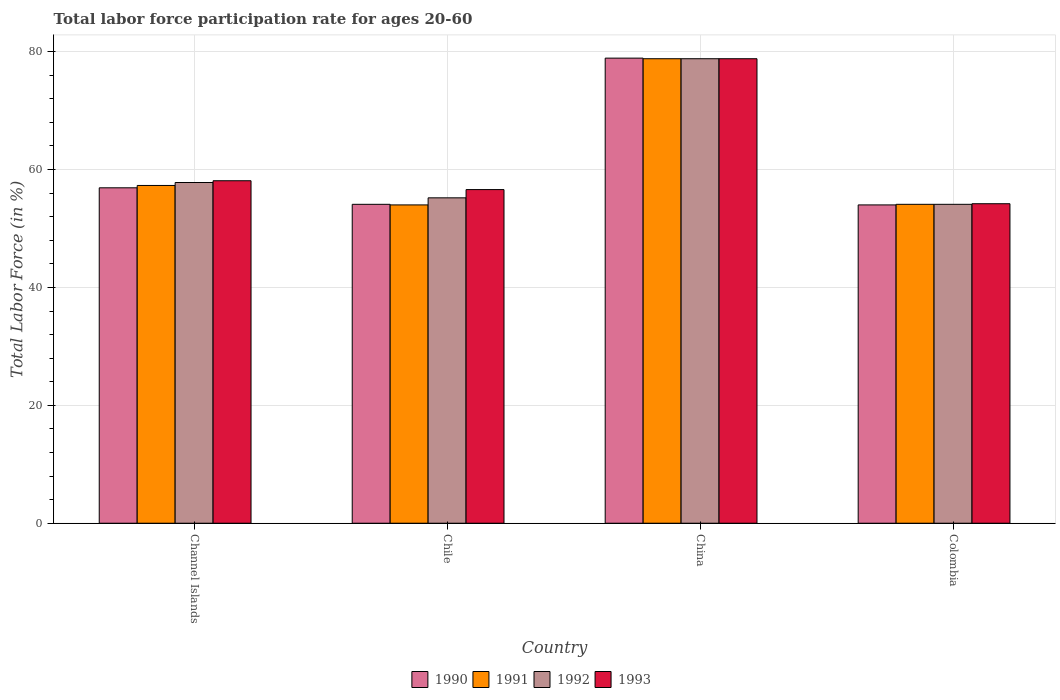How many different coloured bars are there?
Give a very brief answer. 4. Are the number of bars on each tick of the X-axis equal?
Provide a short and direct response. Yes. How many bars are there on the 3rd tick from the left?
Provide a short and direct response. 4. How many bars are there on the 4th tick from the right?
Your answer should be compact. 4. What is the labor force participation rate in 1992 in Channel Islands?
Offer a very short reply. 57.8. Across all countries, what is the maximum labor force participation rate in 1993?
Keep it short and to the point. 78.8. Across all countries, what is the minimum labor force participation rate in 1992?
Your response must be concise. 54.1. What is the total labor force participation rate in 1991 in the graph?
Your response must be concise. 244.2. What is the difference between the labor force participation rate in 1993 in China and that in Colombia?
Provide a succinct answer. 24.6. What is the difference between the labor force participation rate in 1993 in Channel Islands and the labor force participation rate in 1990 in China?
Offer a very short reply. -20.8. What is the average labor force participation rate in 1991 per country?
Give a very brief answer. 61.05. What is the difference between the labor force participation rate of/in 1991 and labor force participation rate of/in 1990 in Chile?
Make the answer very short. -0.1. In how many countries, is the labor force participation rate in 1991 greater than 68 %?
Make the answer very short. 1. What is the ratio of the labor force participation rate in 1990 in Channel Islands to that in Chile?
Keep it short and to the point. 1.05. Is the labor force participation rate in 1993 in Channel Islands less than that in China?
Keep it short and to the point. Yes. Is the difference between the labor force participation rate in 1991 in Channel Islands and Chile greater than the difference between the labor force participation rate in 1990 in Channel Islands and Chile?
Keep it short and to the point. Yes. What is the difference between the highest and the second highest labor force participation rate in 1990?
Your answer should be compact. 2.8. What is the difference between the highest and the lowest labor force participation rate in 1990?
Ensure brevity in your answer.  24.9. In how many countries, is the labor force participation rate in 1993 greater than the average labor force participation rate in 1993 taken over all countries?
Offer a very short reply. 1. Is the sum of the labor force participation rate in 1991 in Channel Islands and Chile greater than the maximum labor force participation rate in 1990 across all countries?
Provide a short and direct response. Yes. Is it the case that in every country, the sum of the labor force participation rate in 1993 and labor force participation rate in 1991 is greater than the sum of labor force participation rate in 1990 and labor force participation rate in 1992?
Your answer should be very brief. No. What is the difference between two consecutive major ticks on the Y-axis?
Offer a terse response. 20. Are the values on the major ticks of Y-axis written in scientific E-notation?
Make the answer very short. No. Where does the legend appear in the graph?
Provide a succinct answer. Bottom center. How many legend labels are there?
Make the answer very short. 4. How are the legend labels stacked?
Provide a short and direct response. Horizontal. What is the title of the graph?
Your answer should be compact. Total labor force participation rate for ages 20-60. Does "2007" appear as one of the legend labels in the graph?
Make the answer very short. No. What is the label or title of the X-axis?
Your answer should be very brief. Country. What is the Total Labor Force (in %) in 1990 in Channel Islands?
Offer a terse response. 56.9. What is the Total Labor Force (in %) in 1991 in Channel Islands?
Make the answer very short. 57.3. What is the Total Labor Force (in %) of 1992 in Channel Islands?
Provide a short and direct response. 57.8. What is the Total Labor Force (in %) of 1993 in Channel Islands?
Offer a very short reply. 58.1. What is the Total Labor Force (in %) of 1990 in Chile?
Keep it short and to the point. 54.1. What is the Total Labor Force (in %) in 1991 in Chile?
Provide a short and direct response. 54. What is the Total Labor Force (in %) of 1992 in Chile?
Your answer should be very brief. 55.2. What is the Total Labor Force (in %) of 1993 in Chile?
Make the answer very short. 56.6. What is the Total Labor Force (in %) of 1990 in China?
Keep it short and to the point. 78.9. What is the Total Labor Force (in %) in 1991 in China?
Offer a terse response. 78.8. What is the Total Labor Force (in %) in 1992 in China?
Make the answer very short. 78.8. What is the Total Labor Force (in %) of 1993 in China?
Provide a succinct answer. 78.8. What is the Total Labor Force (in %) in 1990 in Colombia?
Keep it short and to the point. 54. What is the Total Labor Force (in %) of 1991 in Colombia?
Offer a terse response. 54.1. What is the Total Labor Force (in %) of 1992 in Colombia?
Offer a terse response. 54.1. What is the Total Labor Force (in %) in 1993 in Colombia?
Your answer should be compact. 54.2. Across all countries, what is the maximum Total Labor Force (in %) of 1990?
Ensure brevity in your answer.  78.9. Across all countries, what is the maximum Total Labor Force (in %) in 1991?
Your response must be concise. 78.8. Across all countries, what is the maximum Total Labor Force (in %) in 1992?
Ensure brevity in your answer.  78.8. Across all countries, what is the maximum Total Labor Force (in %) in 1993?
Make the answer very short. 78.8. Across all countries, what is the minimum Total Labor Force (in %) in 1991?
Ensure brevity in your answer.  54. Across all countries, what is the minimum Total Labor Force (in %) of 1992?
Provide a short and direct response. 54.1. Across all countries, what is the minimum Total Labor Force (in %) of 1993?
Make the answer very short. 54.2. What is the total Total Labor Force (in %) of 1990 in the graph?
Offer a very short reply. 243.9. What is the total Total Labor Force (in %) of 1991 in the graph?
Your answer should be compact. 244.2. What is the total Total Labor Force (in %) of 1992 in the graph?
Offer a very short reply. 245.9. What is the total Total Labor Force (in %) of 1993 in the graph?
Provide a short and direct response. 247.7. What is the difference between the Total Labor Force (in %) in 1990 in Channel Islands and that in Chile?
Ensure brevity in your answer.  2.8. What is the difference between the Total Labor Force (in %) of 1993 in Channel Islands and that in Chile?
Your answer should be compact. 1.5. What is the difference between the Total Labor Force (in %) in 1991 in Channel Islands and that in China?
Your answer should be compact. -21.5. What is the difference between the Total Labor Force (in %) in 1992 in Channel Islands and that in China?
Keep it short and to the point. -21. What is the difference between the Total Labor Force (in %) of 1993 in Channel Islands and that in China?
Keep it short and to the point. -20.7. What is the difference between the Total Labor Force (in %) in 1990 in Channel Islands and that in Colombia?
Ensure brevity in your answer.  2.9. What is the difference between the Total Labor Force (in %) in 1991 in Channel Islands and that in Colombia?
Your answer should be very brief. 3.2. What is the difference between the Total Labor Force (in %) in 1993 in Channel Islands and that in Colombia?
Keep it short and to the point. 3.9. What is the difference between the Total Labor Force (in %) of 1990 in Chile and that in China?
Keep it short and to the point. -24.8. What is the difference between the Total Labor Force (in %) of 1991 in Chile and that in China?
Ensure brevity in your answer.  -24.8. What is the difference between the Total Labor Force (in %) in 1992 in Chile and that in China?
Offer a terse response. -23.6. What is the difference between the Total Labor Force (in %) in 1993 in Chile and that in China?
Make the answer very short. -22.2. What is the difference between the Total Labor Force (in %) of 1992 in Chile and that in Colombia?
Provide a short and direct response. 1.1. What is the difference between the Total Labor Force (in %) in 1990 in China and that in Colombia?
Make the answer very short. 24.9. What is the difference between the Total Labor Force (in %) of 1991 in China and that in Colombia?
Ensure brevity in your answer.  24.7. What is the difference between the Total Labor Force (in %) in 1992 in China and that in Colombia?
Provide a short and direct response. 24.7. What is the difference between the Total Labor Force (in %) of 1993 in China and that in Colombia?
Keep it short and to the point. 24.6. What is the difference between the Total Labor Force (in %) of 1990 in Channel Islands and the Total Labor Force (in %) of 1991 in Chile?
Your answer should be compact. 2.9. What is the difference between the Total Labor Force (in %) in 1990 in Channel Islands and the Total Labor Force (in %) in 1992 in Chile?
Offer a very short reply. 1.7. What is the difference between the Total Labor Force (in %) in 1992 in Channel Islands and the Total Labor Force (in %) in 1993 in Chile?
Give a very brief answer. 1.2. What is the difference between the Total Labor Force (in %) in 1990 in Channel Islands and the Total Labor Force (in %) in 1991 in China?
Give a very brief answer. -21.9. What is the difference between the Total Labor Force (in %) in 1990 in Channel Islands and the Total Labor Force (in %) in 1992 in China?
Your answer should be very brief. -21.9. What is the difference between the Total Labor Force (in %) in 1990 in Channel Islands and the Total Labor Force (in %) in 1993 in China?
Your answer should be very brief. -21.9. What is the difference between the Total Labor Force (in %) in 1991 in Channel Islands and the Total Labor Force (in %) in 1992 in China?
Ensure brevity in your answer.  -21.5. What is the difference between the Total Labor Force (in %) in 1991 in Channel Islands and the Total Labor Force (in %) in 1993 in China?
Offer a very short reply. -21.5. What is the difference between the Total Labor Force (in %) in 1992 in Channel Islands and the Total Labor Force (in %) in 1993 in China?
Provide a succinct answer. -21. What is the difference between the Total Labor Force (in %) in 1990 in Channel Islands and the Total Labor Force (in %) in 1991 in Colombia?
Provide a succinct answer. 2.8. What is the difference between the Total Labor Force (in %) of 1990 in Channel Islands and the Total Labor Force (in %) of 1993 in Colombia?
Give a very brief answer. 2.7. What is the difference between the Total Labor Force (in %) in 1991 in Channel Islands and the Total Labor Force (in %) in 1992 in Colombia?
Offer a very short reply. 3.2. What is the difference between the Total Labor Force (in %) of 1992 in Channel Islands and the Total Labor Force (in %) of 1993 in Colombia?
Your response must be concise. 3.6. What is the difference between the Total Labor Force (in %) in 1990 in Chile and the Total Labor Force (in %) in 1991 in China?
Provide a short and direct response. -24.7. What is the difference between the Total Labor Force (in %) in 1990 in Chile and the Total Labor Force (in %) in 1992 in China?
Provide a succinct answer. -24.7. What is the difference between the Total Labor Force (in %) in 1990 in Chile and the Total Labor Force (in %) in 1993 in China?
Give a very brief answer. -24.7. What is the difference between the Total Labor Force (in %) of 1991 in Chile and the Total Labor Force (in %) of 1992 in China?
Provide a succinct answer. -24.8. What is the difference between the Total Labor Force (in %) of 1991 in Chile and the Total Labor Force (in %) of 1993 in China?
Provide a succinct answer. -24.8. What is the difference between the Total Labor Force (in %) of 1992 in Chile and the Total Labor Force (in %) of 1993 in China?
Offer a terse response. -23.6. What is the difference between the Total Labor Force (in %) of 1991 in Chile and the Total Labor Force (in %) of 1992 in Colombia?
Offer a terse response. -0.1. What is the difference between the Total Labor Force (in %) in 1990 in China and the Total Labor Force (in %) in 1991 in Colombia?
Your answer should be compact. 24.8. What is the difference between the Total Labor Force (in %) of 1990 in China and the Total Labor Force (in %) of 1992 in Colombia?
Provide a short and direct response. 24.8. What is the difference between the Total Labor Force (in %) of 1990 in China and the Total Labor Force (in %) of 1993 in Colombia?
Your response must be concise. 24.7. What is the difference between the Total Labor Force (in %) of 1991 in China and the Total Labor Force (in %) of 1992 in Colombia?
Your answer should be very brief. 24.7. What is the difference between the Total Labor Force (in %) in 1991 in China and the Total Labor Force (in %) in 1993 in Colombia?
Provide a succinct answer. 24.6. What is the difference between the Total Labor Force (in %) of 1992 in China and the Total Labor Force (in %) of 1993 in Colombia?
Give a very brief answer. 24.6. What is the average Total Labor Force (in %) of 1990 per country?
Keep it short and to the point. 60.98. What is the average Total Labor Force (in %) in 1991 per country?
Give a very brief answer. 61.05. What is the average Total Labor Force (in %) in 1992 per country?
Your response must be concise. 61.48. What is the average Total Labor Force (in %) in 1993 per country?
Offer a very short reply. 61.92. What is the difference between the Total Labor Force (in %) in 1990 and Total Labor Force (in %) in 1991 in Channel Islands?
Offer a terse response. -0.4. What is the difference between the Total Labor Force (in %) in 1990 and Total Labor Force (in %) in 1993 in Channel Islands?
Give a very brief answer. -1.2. What is the difference between the Total Labor Force (in %) of 1991 and Total Labor Force (in %) of 1992 in Channel Islands?
Your response must be concise. -0.5. What is the difference between the Total Labor Force (in %) of 1990 and Total Labor Force (in %) of 1991 in Chile?
Offer a very short reply. 0.1. What is the difference between the Total Labor Force (in %) of 1990 and Total Labor Force (in %) of 1992 in Chile?
Provide a succinct answer. -1.1. What is the difference between the Total Labor Force (in %) in 1990 and Total Labor Force (in %) in 1993 in Chile?
Your answer should be very brief. -2.5. What is the difference between the Total Labor Force (in %) in 1991 and Total Labor Force (in %) in 1992 in Chile?
Offer a very short reply. -1.2. What is the difference between the Total Labor Force (in %) of 1991 and Total Labor Force (in %) of 1993 in Chile?
Provide a succinct answer. -2.6. What is the difference between the Total Labor Force (in %) in 1990 and Total Labor Force (in %) in 1991 in China?
Make the answer very short. 0.1. What is the difference between the Total Labor Force (in %) of 1990 and Total Labor Force (in %) of 1992 in China?
Offer a very short reply. 0.1. What is the difference between the Total Labor Force (in %) of 1990 and Total Labor Force (in %) of 1993 in China?
Give a very brief answer. 0.1. What is the difference between the Total Labor Force (in %) of 1991 and Total Labor Force (in %) of 1993 in China?
Give a very brief answer. 0. What is the difference between the Total Labor Force (in %) of 1992 and Total Labor Force (in %) of 1993 in China?
Your answer should be compact. 0. What is the difference between the Total Labor Force (in %) in 1990 and Total Labor Force (in %) in 1992 in Colombia?
Provide a succinct answer. -0.1. What is the difference between the Total Labor Force (in %) in 1990 and Total Labor Force (in %) in 1993 in Colombia?
Ensure brevity in your answer.  -0.2. What is the difference between the Total Labor Force (in %) of 1991 and Total Labor Force (in %) of 1993 in Colombia?
Ensure brevity in your answer.  -0.1. What is the difference between the Total Labor Force (in %) in 1992 and Total Labor Force (in %) in 1993 in Colombia?
Provide a short and direct response. -0.1. What is the ratio of the Total Labor Force (in %) of 1990 in Channel Islands to that in Chile?
Provide a succinct answer. 1.05. What is the ratio of the Total Labor Force (in %) of 1991 in Channel Islands to that in Chile?
Make the answer very short. 1.06. What is the ratio of the Total Labor Force (in %) of 1992 in Channel Islands to that in Chile?
Provide a short and direct response. 1.05. What is the ratio of the Total Labor Force (in %) of 1993 in Channel Islands to that in Chile?
Make the answer very short. 1.03. What is the ratio of the Total Labor Force (in %) of 1990 in Channel Islands to that in China?
Ensure brevity in your answer.  0.72. What is the ratio of the Total Labor Force (in %) in 1991 in Channel Islands to that in China?
Provide a short and direct response. 0.73. What is the ratio of the Total Labor Force (in %) of 1992 in Channel Islands to that in China?
Give a very brief answer. 0.73. What is the ratio of the Total Labor Force (in %) of 1993 in Channel Islands to that in China?
Make the answer very short. 0.74. What is the ratio of the Total Labor Force (in %) of 1990 in Channel Islands to that in Colombia?
Your answer should be compact. 1.05. What is the ratio of the Total Labor Force (in %) of 1991 in Channel Islands to that in Colombia?
Give a very brief answer. 1.06. What is the ratio of the Total Labor Force (in %) in 1992 in Channel Islands to that in Colombia?
Keep it short and to the point. 1.07. What is the ratio of the Total Labor Force (in %) in 1993 in Channel Islands to that in Colombia?
Your answer should be compact. 1.07. What is the ratio of the Total Labor Force (in %) of 1990 in Chile to that in China?
Ensure brevity in your answer.  0.69. What is the ratio of the Total Labor Force (in %) of 1991 in Chile to that in China?
Give a very brief answer. 0.69. What is the ratio of the Total Labor Force (in %) in 1992 in Chile to that in China?
Provide a succinct answer. 0.7. What is the ratio of the Total Labor Force (in %) in 1993 in Chile to that in China?
Offer a terse response. 0.72. What is the ratio of the Total Labor Force (in %) of 1990 in Chile to that in Colombia?
Your answer should be very brief. 1. What is the ratio of the Total Labor Force (in %) in 1992 in Chile to that in Colombia?
Offer a very short reply. 1.02. What is the ratio of the Total Labor Force (in %) in 1993 in Chile to that in Colombia?
Give a very brief answer. 1.04. What is the ratio of the Total Labor Force (in %) of 1990 in China to that in Colombia?
Your answer should be very brief. 1.46. What is the ratio of the Total Labor Force (in %) of 1991 in China to that in Colombia?
Your answer should be very brief. 1.46. What is the ratio of the Total Labor Force (in %) of 1992 in China to that in Colombia?
Keep it short and to the point. 1.46. What is the ratio of the Total Labor Force (in %) in 1993 in China to that in Colombia?
Your answer should be very brief. 1.45. What is the difference between the highest and the second highest Total Labor Force (in %) in 1990?
Offer a very short reply. 22. What is the difference between the highest and the second highest Total Labor Force (in %) in 1991?
Your answer should be compact. 21.5. What is the difference between the highest and the second highest Total Labor Force (in %) of 1992?
Offer a terse response. 21. What is the difference between the highest and the second highest Total Labor Force (in %) of 1993?
Your answer should be very brief. 20.7. What is the difference between the highest and the lowest Total Labor Force (in %) of 1990?
Your answer should be compact. 24.9. What is the difference between the highest and the lowest Total Labor Force (in %) in 1991?
Offer a terse response. 24.8. What is the difference between the highest and the lowest Total Labor Force (in %) of 1992?
Ensure brevity in your answer.  24.7. What is the difference between the highest and the lowest Total Labor Force (in %) of 1993?
Offer a very short reply. 24.6. 